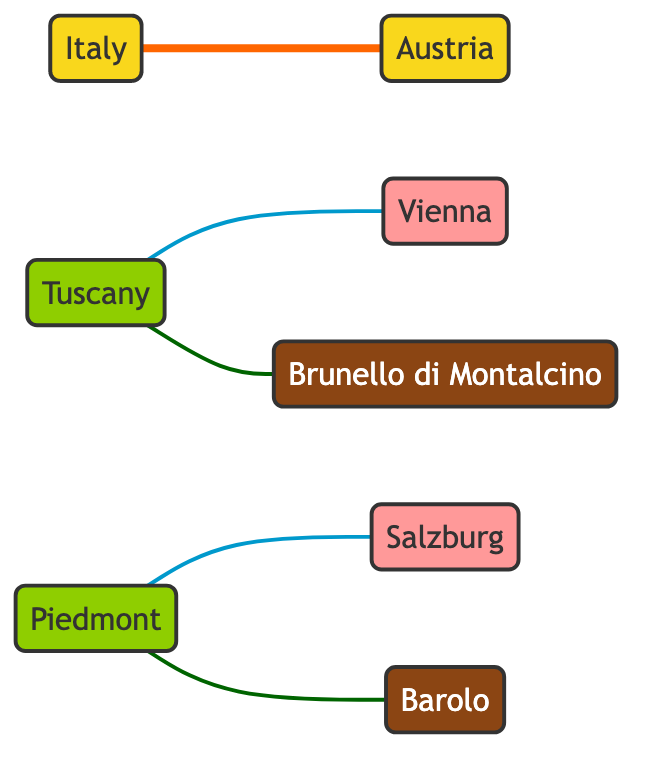What countries are involved in the trade partnership? The diagram shows a direct connection between Italy and Austria, indicating they are the countries involved in the trade partnership.
Answer: Italy and Austria How many regions are represented in the diagram? The diagram contains two distinct regions, Tuscany and Piedmont, as indicated by the labeled nodes.
Answer: 2 Which city is connected to Tuscan wines? Tuscany is connected to the city Vienna through the export route for Brunello di Montalcino wines, showing the city associated with Tuscan wines.
Answer: Vienna What type of relationship exists between Italy and Austria? The diagram explicitly classifies the relationship between Italy and Austria as a trade partnership, showcasing their collaboration in premium wine trade.
Answer: Trade Partnership How many types of wines are mentioned in the diagram? The nodes in the diagram identify two specific wines, Brunello di Montalcino and Barolo, showing the types of wines appreciated in this trade.
Answer: 2 How are Barolo wines exported to Austria? The diagram displays a direct edge connecting Piedmont to Salzburg, depicting the export route whereby Barolo wines reach Austrian markets.
Answer: Through Salzburg Which region produces Brunello di Montalcino? In the diagram, an edge indicates that Tuscany produces Brunello di Montalcino, showing the region responsible for this particular wine.
Answer: Tuscany Is there a direct trade connection from Tuscany to Salzburg? The diagram does not illustrate a direct connection between Tuscany and Salzburg; it shows separate routes leading to different Austrian cities.
Answer: No Which wine is primarily associated with Piedmont? The diagram identifies Barolo as the wine produced in the Piedmont region, establishing its association through the edges presented.
Answer: Barolo What is the export route for Brunello di Montalcino? The diagram provides a direct connection from Tuscany to Vienna, which indicates the route for exporting Brunello di Montalcino to Austrian markets.
Answer: Tuscany to Vienna 